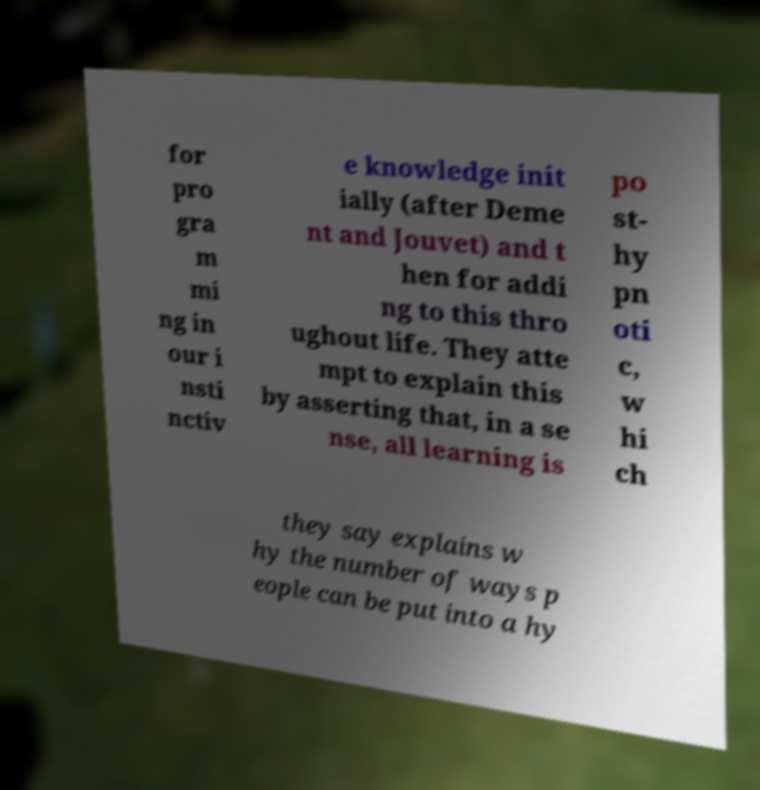Could you extract and type out the text from this image? for pro gra m mi ng in our i nsti nctiv e knowledge init ially (after Deme nt and Jouvet) and t hen for addi ng to this thro ughout life. They atte mpt to explain this by asserting that, in a se nse, all learning is po st- hy pn oti c, w hi ch they say explains w hy the number of ways p eople can be put into a hy 